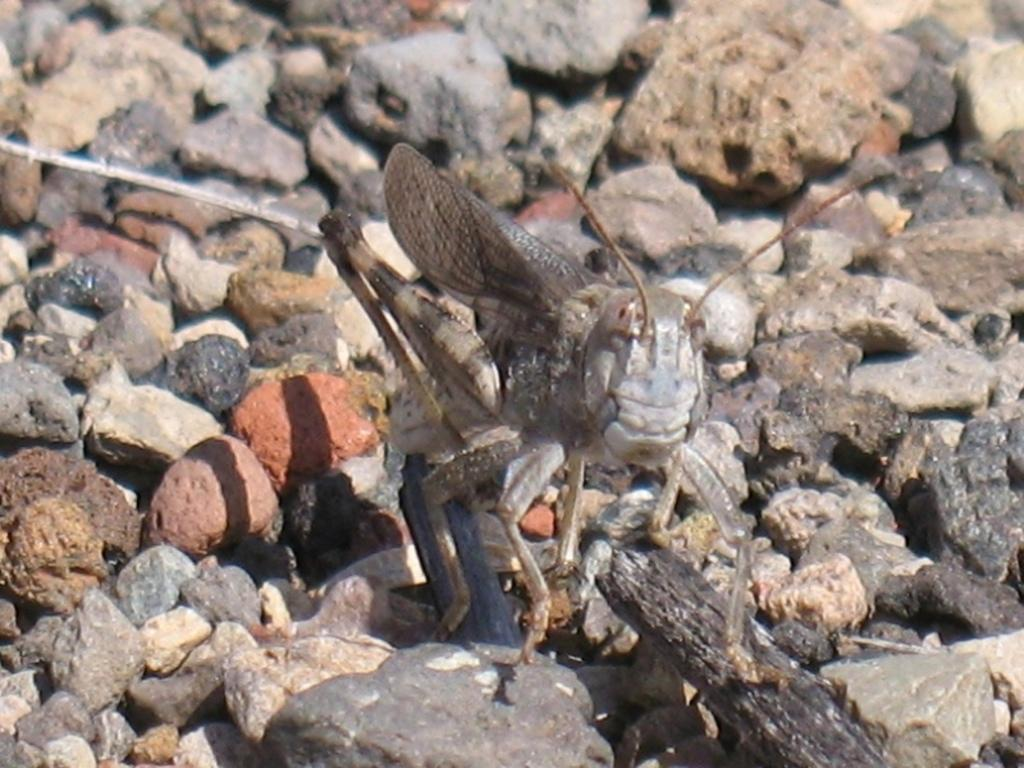What type of insect is in the image? There is a band wing grasshopper in the image. Where is the grasshopper located? The grasshopper is present on the ground. What else can be seen in the image besides the grasshopper? There are stones present in the image. What does the caption say about the scarecrow in the image? There is no scarecrow or caption present in the image. 